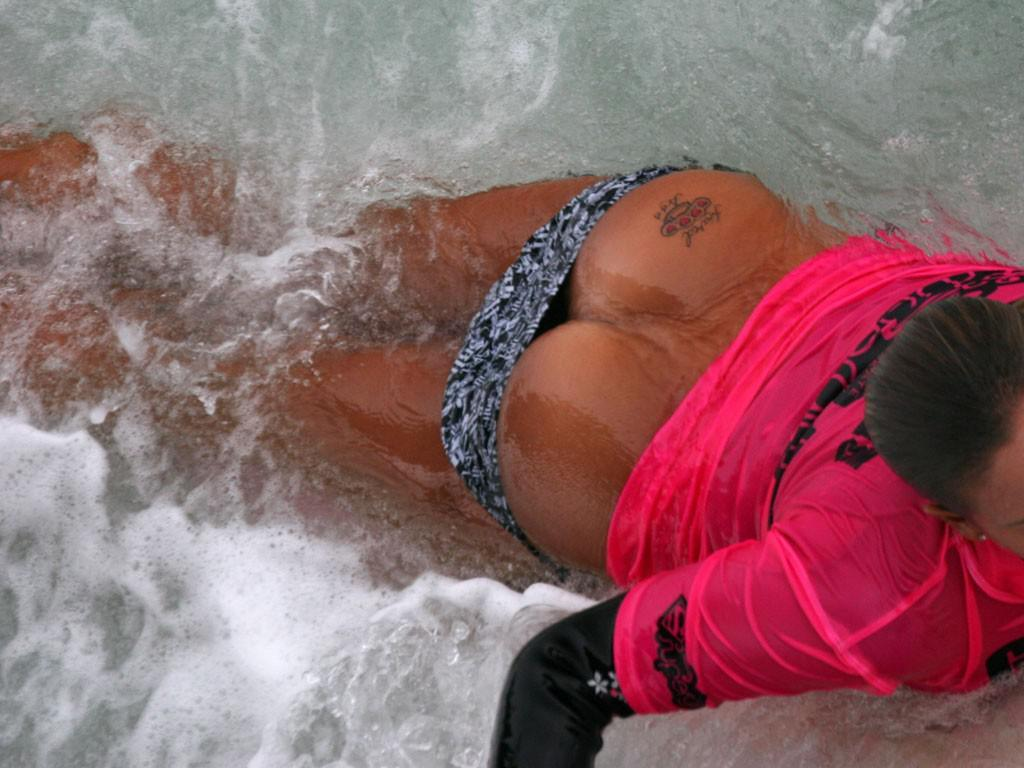What is happening in the image? There is a person in the image, and they are swimming in the water. Can you describe the person's activity in more detail? The person is swimming, which involves moving through the water using their arms and legs. What type of knot is the person using to swim in the image? There is no knot mentioned or visible in the image; the person is swimming using their arms and legs. What disease is the person suffering from in the image? There is no indication of any disease in the image; the person is simply swimming in the water. 